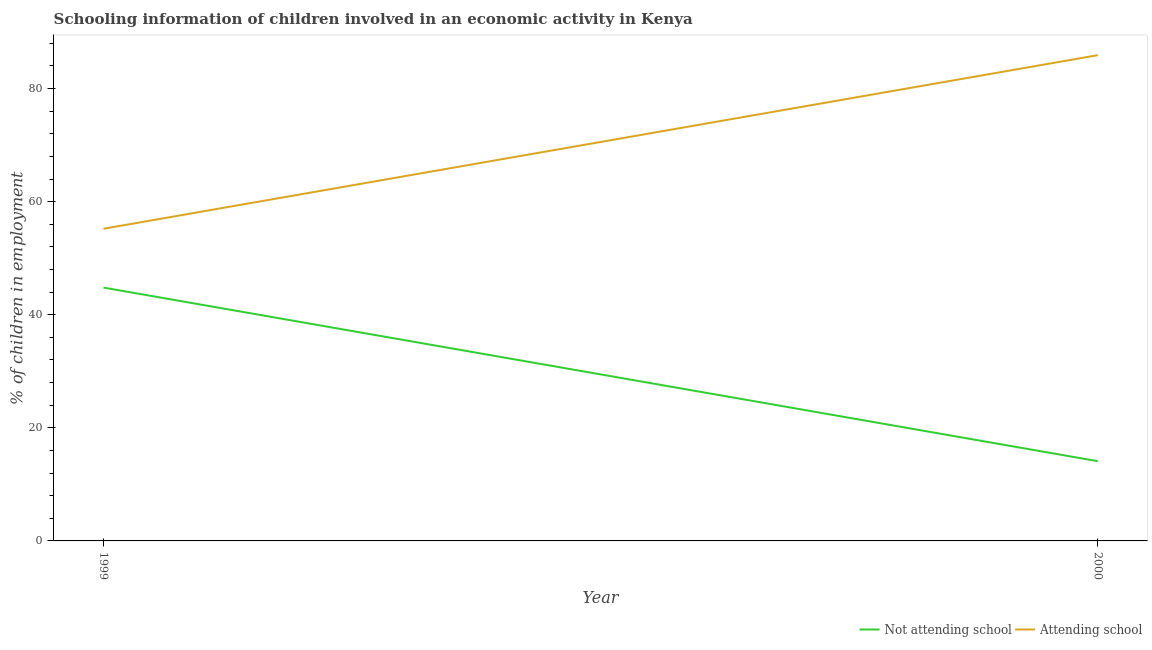How many different coloured lines are there?
Offer a very short reply. 2. Across all years, what is the maximum percentage of employed children who are not attending school?
Your answer should be compact. 44.8. Across all years, what is the minimum percentage of employed children who are attending school?
Your response must be concise. 55.2. In which year was the percentage of employed children who are attending school maximum?
Provide a succinct answer. 2000. What is the total percentage of employed children who are attending school in the graph?
Offer a terse response. 141.1. What is the difference between the percentage of employed children who are not attending school in 1999 and that in 2000?
Your response must be concise. 30.7. What is the difference between the percentage of employed children who are attending school in 1999 and the percentage of employed children who are not attending school in 2000?
Your answer should be very brief. 41.1. What is the average percentage of employed children who are attending school per year?
Make the answer very short. 70.55. In the year 1999, what is the difference between the percentage of employed children who are attending school and percentage of employed children who are not attending school?
Your response must be concise. 10.4. In how many years, is the percentage of employed children who are attending school greater than 48 %?
Your response must be concise. 2. What is the ratio of the percentage of employed children who are attending school in 1999 to that in 2000?
Ensure brevity in your answer.  0.64. Does the percentage of employed children who are attending school monotonically increase over the years?
Make the answer very short. Yes. How many lines are there?
Provide a short and direct response. 2. How many years are there in the graph?
Your answer should be compact. 2. Where does the legend appear in the graph?
Keep it short and to the point. Bottom right. What is the title of the graph?
Your answer should be very brief. Schooling information of children involved in an economic activity in Kenya. Does "Imports" appear as one of the legend labels in the graph?
Your answer should be compact. No. What is the label or title of the Y-axis?
Offer a terse response. % of children in employment. What is the % of children in employment in Not attending school in 1999?
Provide a short and direct response. 44.8. What is the % of children in employment in Attending school in 1999?
Your answer should be very brief. 55.2. What is the % of children in employment of Not attending school in 2000?
Your answer should be very brief. 14.1. What is the % of children in employment in Attending school in 2000?
Make the answer very short. 85.9. Across all years, what is the maximum % of children in employment in Not attending school?
Your response must be concise. 44.8. Across all years, what is the maximum % of children in employment in Attending school?
Make the answer very short. 85.9. Across all years, what is the minimum % of children in employment in Not attending school?
Keep it short and to the point. 14.1. Across all years, what is the minimum % of children in employment in Attending school?
Provide a succinct answer. 55.2. What is the total % of children in employment in Not attending school in the graph?
Give a very brief answer. 58.9. What is the total % of children in employment of Attending school in the graph?
Provide a succinct answer. 141.1. What is the difference between the % of children in employment of Not attending school in 1999 and that in 2000?
Provide a short and direct response. 30.7. What is the difference between the % of children in employment of Attending school in 1999 and that in 2000?
Ensure brevity in your answer.  -30.7. What is the difference between the % of children in employment in Not attending school in 1999 and the % of children in employment in Attending school in 2000?
Your response must be concise. -41.1. What is the average % of children in employment in Not attending school per year?
Keep it short and to the point. 29.45. What is the average % of children in employment of Attending school per year?
Your answer should be very brief. 70.55. In the year 2000, what is the difference between the % of children in employment of Not attending school and % of children in employment of Attending school?
Give a very brief answer. -71.8. What is the ratio of the % of children in employment of Not attending school in 1999 to that in 2000?
Your response must be concise. 3.18. What is the ratio of the % of children in employment of Attending school in 1999 to that in 2000?
Your answer should be compact. 0.64. What is the difference between the highest and the second highest % of children in employment of Not attending school?
Offer a terse response. 30.7. What is the difference between the highest and the second highest % of children in employment of Attending school?
Ensure brevity in your answer.  30.7. What is the difference between the highest and the lowest % of children in employment of Not attending school?
Offer a terse response. 30.7. What is the difference between the highest and the lowest % of children in employment in Attending school?
Keep it short and to the point. 30.7. 